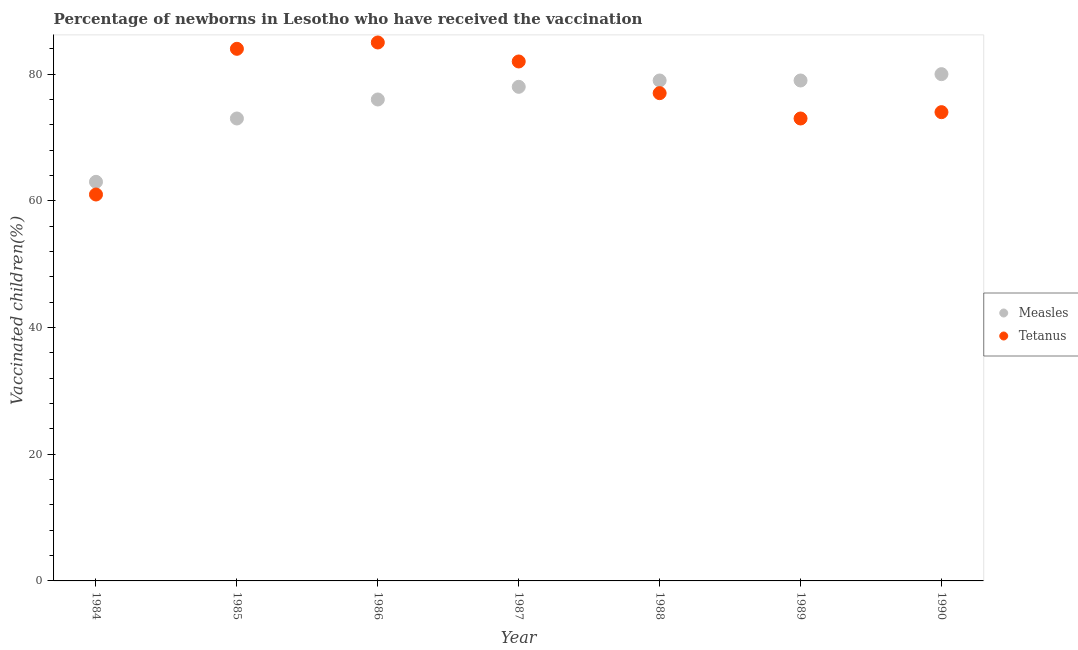What is the percentage of newborns who received vaccination for measles in 1985?
Make the answer very short. 73. Across all years, what is the maximum percentage of newborns who received vaccination for measles?
Ensure brevity in your answer.  80. Across all years, what is the minimum percentage of newborns who received vaccination for tetanus?
Your answer should be very brief. 61. What is the total percentage of newborns who received vaccination for tetanus in the graph?
Your response must be concise. 536. What is the difference between the percentage of newborns who received vaccination for tetanus in 1985 and that in 1990?
Your answer should be very brief. 10. What is the difference between the percentage of newborns who received vaccination for measles in 1986 and the percentage of newborns who received vaccination for tetanus in 1984?
Your response must be concise. 15. What is the average percentage of newborns who received vaccination for measles per year?
Provide a short and direct response. 75.43. In the year 1986, what is the difference between the percentage of newborns who received vaccination for measles and percentage of newborns who received vaccination for tetanus?
Your response must be concise. -9. What is the ratio of the percentage of newborns who received vaccination for measles in 1984 to that in 1989?
Your answer should be compact. 0.8. Is the percentage of newborns who received vaccination for measles in 1988 less than that in 1990?
Offer a very short reply. Yes. What is the difference between the highest and the second highest percentage of newborns who received vaccination for tetanus?
Your response must be concise. 1. What is the difference between the highest and the lowest percentage of newborns who received vaccination for measles?
Provide a short and direct response. 17. Is the percentage of newborns who received vaccination for tetanus strictly greater than the percentage of newborns who received vaccination for measles over the years?
Provide a succinct answer. No. How many dotlines are there?
Make the answer very short. 2. What is the difference between two consecutive major ticks on the Y-axis?
Provide a succinct answer. 20. Does the graph contain any zero values?
Provide a succinct answer. No. Where does the legend appear in the graph?
Keep it short and to the point. Center right. How many legend labels are there?
Your answer should be compact. 2. What is the title of the graph?
Make the answer very short. Percentage of newborns in Lesotho who have received the vaccination. What is the label or title of the Y-axis?
Your answer should be compact. Vaccinated children(%)
. What is the Vaccinated children(%)
 of Measles in 1984?
Provide a succinct answer. 63. What is the Vaccinated children(%)
 in Measles in 1986?
Offer a terse response. 76. What is the Vaccinated children(%)
 in Measles in 1988?
Make the answer very short. 79. What is the Vaccinated children(%)
 in Tetanus in 1988?
Offer a terse response. 77. What is the Vaccinated children(%)
 of Measles in 1989?
Provide a succinct answer. 79. What is the Vaccinated children(%)
 of Tetanus in 1989?
Make the answer very short. 73. What is the Vaccinated children(%)
 of Tetanus in 1990?
Provide a succinct answer. 74. Across all years, what is the maximum Vaccinated children(%)
 in Measles?
Give a very brief answer. 80. Across all years, what is the maximum Vaccinated children(%)
 in Tetanus?
Ensure brevity in your answer.  85. Across all years, what is the minimum Vaccinated children(%)
 of Measles?
Offer a very short reply. 63. Across all years, what is the minimum Vaccinated children(%)
 in Tetanus?
Keep it short and to the point. 61. What is the total Vaccinated children(%)
 of Measles in the graph?
Your answer should be compact. 528. What is the total Vaccinated children(%)
 in Tetanus in the graph?
Your answer should be compact. 536. What is the difference between the Vaccinated children(%)
 in Measles in 1984 and that in 1985?
Ensure brevity in your answer.  -10. What is the difference between the Vaccinated children(%)
 of Tetanus in 1984 and that in 1985?
Provide a short and direct response. -23. What is the difference between the Vaccinated children(%)
 in Measles in 1984 and that in 1986?
Your response must be concise. -13. What is the difference between the Vaccinated children(%)
 of Measles in 1984 and that in 1987?
Your response must be concise. -15. What is the difference between the Vaccinated children(%)
 of Tetanus in 1984 and that in 1987?
Offer a very short reply. -21. What is the difference between the Vaccinated children(%)
 of Measles in 1984 and that in 1988?
Your response must be concise. -16. What is the difference between the Vaccinated children(%)
 in Measles in 1984 and that in 1989?
Offer a terse response. -16. What is the difference between the Vaccinated children(%)
 of Tetanus in 1985 and that in 1986?
Keep it short and to the point. -1. What is the difference between the Vaccinated children(%)
 in Tetanus in 1985 and that in 1987?
Your answer should be compact. 2. What is the difference between the Vaccinated children(%)
 in Tetanus in 1985 and that in 1988?
Make the answer very short. 7. What is the difference between the Vaccinated children(%)
 in Tetanus in 1985 and that in 1989?
Keep it short and to the point. 11. What is the difference between the Vaccinated children(%)
 of Measles in 1985 and that in 1990?
Ensure brevity in your answer.  -7. What is the difference between the Vaccinated children(%)
 in Tetanus in 1985 and that in 1990?
Provide a succinct answer. 10. What is the difference between the Vaccinated children(%)
 in Measles in 1986 and that in 1987?
Ensure brevity in your answer.  -2. What is the difference between the Vaccinated children(%)
 of Tetanus in 1986 and that in 1989?
Your answer should be compact. 12. What is the difference between the Vaccinated children(%)
 of Tetanus in 1986 and that in 1990?
Your answer should be very brief. 11. What is the difference between the Vaccinated children(%)
 of Measles in 1987 and that in 1988?
Give a very brief answer. -1. What is the difference between the Vaccinated children(%)
 in Tetanus in 1987 and that in 1988?
Offer a terse response. 5. What is the difference between the Vaccinated children(%)
 in Tetanus in 1987 and that in 1990?
Your answer should be very brief. 8. What is the difference between the Vaccinated children(%)
 of Measles in 1988 and that in 1989?
Keep it short and to the point. 0. What is the difference between the Vaccinated children(%)
 in Tetanus in 1988 and that in 1989?
Make the answer very short. 4. What is the difference between the Vaccinated children(%)
 in Measles in 1989 and that in 1990?
Offer a very short reply. -1. What is the difference between the Vaccinated children(%)
 of Measles in 1984 and the Vaccinated children(%)
 of Tetanus in 1988?
Offer a very short reply. -14. What is the difference between the Vaccinated children(%)
 of Measles in 1985 and the Vaccinated children(%)
 of Tetanus in 1987?
Ensure brevity in your answer.  -9. What is the difference between the Vaccinated children(%)
 of Measles in 1985 and the Vaccinated children(%)
 of Tetanus in 1988?
Ensure brevity in your answer.  -4. What is the difference between the Vaccinated children(%)
 in Measles in 1985 and the Vaccinated children(%)
 in Tetanus in 1989?
Ensure brevity in your answer.  0. What is the difference between the Vaccinated children(%)
 in Measles in 1985 and the Vaccinated children(%)
 in Tetanus in 1990?
Your response must be concise. -1. What is the difference between the Vaccinated children(%)
 in Measles in 1986 and the Vaccinated children(%)
 in Tetanus in 1987?
Provide a succinct answer. -6. What is the difference between the Vaccinated children(%)
 of Measles in 1986 and the Vaccinated children(%)
 of Tetanus in 1989?
Offer a very short reply. 3. What is the difference between the Vaccinated children(%)
 in Measles in 1987 and the Vaccinated children(%)
 in Tetanus in 1990?
Make the answer very short. 4. What is the difference between the Vaccinated children(%)
 of Measles in 1988 and the Vaccinated children(%)
 of Tetanus in 1990?
Your answer should be compact. 5. What is the difference between the Vaccinated children(%)
 in Measles in 1989 and the Vaccinated children(%)
 in Tetanus in 1990?
Offer a terse response. 5. What is the average Vaccinated children(%)
 in Measles per year?
Ensure brevity in your answer.  75.43. What is the average Vaccinated children(%)
 of Tetanus per year?
Offer a very short reply. 76.57. In the year 1984, what is the difference between the Vaccinated children(%)
 in Measles and Vaccinated children(%)
 in Tetanus?
Your answer should be very brief. 2. In the year 1987, what is the difference between the Vaccinated children(%)
 of Measles and Vaccinated children(%)
 of Tetanus?
Give a very brief answer. -4. In the year 1988, what is the difference between the Vaccinated children(%)
 in Measles and Vaccinated children(%)
 in Tetanus?
Keep it short and to the point. 2. In the year 1989, what is the difference between the Vaccinated children(%)
 in Measles and Vaccinated children(%)
 in Tetanus?
Offer a very short reply. 6. In the year 1990, what is the difference between the Vaccinated children(%)
 in Measles and Vaccinated children(%)
 in Tetanus?
Offer a terse response. 6. What is the ratio of the Vaccinated children(%)
 in Measles in 1984 to that in 1985?
Provide a succinct answer. 0.86. What is the ratio of the Vaccinated children(%)
 in Tetanus in 1984 to that in 1985?
Offer a terse response. 0.73. What is the ratio of the Vaccinated children(%)
 of Measles in 1984 to that in 1986?
Offer a very short reply. 0.83. What is the ratio of the Vaccinated children(%)
 of Tetanus in 1984 to that in 1986?
Provide a short and direct response. 0.72. What is the ratio of the Vaccinated children(%)
 of Measles in 1984 to that in 1987?
Keep it short and to the point. 0.81. What is the ratio of the Vaccinated children(%)
 of Tetanus in 1984 to that in 1987?
Your answer should be very brief. 0.74. What is the ratio of the Vaccinated children(%)
 of Measles in 1984 to that in 1988?
Give a very brief answer. 0.8. What is the ratio of the Vaccinated children(%)
 in Tetanus in 1984 to that in 1988?
Ensure brevity in your answer.  0.79. What is the ratio of the Vaccinated children(%)
 in Measles in 1984 to that in 1989?
Keep it short and to the point. 0.8. What is the ratio of the Vaccinated children(%)
 in Tetanus in 1984 to that in 1989?
Keep it short and to the point. 0.84. What is the ratio of the Vaccinated children(%)
 of Measles in 1984 to that in 1990?
Keep it short and to the point. 0.79. What is the ratio of the Vaccinated children(%)
 of Tetanus in 1984 to that in 1990?
Your answer should be very brief. 0.82. What is the ratio of the Vaccinated children(%)
 of Measles in 1985 to that in 1986?
Your answer should be very brief. 0.96. What is the ratio of the Vaccinated children(%)
 in Measles in 1985 to that in 1987?
Give a very brief answer. 0.94. What is the ratio of the Vaccinated children(%)
 of Tetanus in 1985 to that in 1987?
Ensure brevity in your answer.  1.02. What is the ratio of the Vaccinated children(%)
 of Measles in 1985 to that in 1988?
Your answer should be compact. 0.92. What is the ratio of the Vaccinated children(%)
 of Tetanus in 1985 to that in 1988?
Your answer should be very brief. 1.09. What is the ratio of the Vaccinated children(%)
 of Measles in 1985 to that in 1989?
Give a very brief answer. 0.92. What is the ratio of the Vaccinated children(%)
 in Tetanus in 1985 to that in 1989?
Your response must be concise. 1.15. What is the ratio of the Vaccinated children(%)
 of Measles in 1985 to that in 1990?
Your answer should be compact. 0.91. What is the ratio of the Vaccinated children(%)
 of Tetanus in 1985 to that in 1990?
Provide a succinct answer. 1.14. What is the ratio of the Vaccinated children(%)
 in Measles in 1986 to that in 1987?
Offer a terse response. 0.97. What is the ratio of the Vaccinated children(%)
 in Tetanus in 1986 to that in 1987?
Provide a succinct answer. 1.04. What is the ratio of the Vaccinated children(%)
 of Tetanus in 1986 to that in 1988?
Your answer should be compact. 1.1. What is the ratio of the Vaccinated children(%)
 of Tetanus in 1986 to that in 1989?
Keep it short and to the point. 1.16. What is the ratio of the Vaccinated children(%)
 of Measles in 1986 to that in 1990?
Keep it short and to the point. 0.95. What is the ratio of the Vaccinated children(%)
 in Tetanus in 1986 to that in 1990?
Your answer should be very brief. 1.15. What is the ratio of the Vaccinated children(%)
 of Measles in 1987 to that in 1988?
Make the answer very short. 0.99. What is the ratio of the Vaccinated children(%)
 of Tetanus in 1987 to that in 1988?
Keep it short and to the point. 1.06. What is the ratio of the Vaccinated children(%)
 of Measles in 1987 to that in 1989?
Make the answer very short. 0.99. What is the ratio of the Vaccinated children(%)
 of Tetanus in 1987 to that in 1989?
Offer a very short reply. 1.12. What is the ratio of the Vaccinated children(%)
 of Tetanus in 1987 to that in 1990?
Your answer should be compact. 1.11. What is the ratio of the Vaccinated children(%)
 in Tetanus in 1988 to that in 1989?
Keep it short and to the point. 1.05. What is the ratio of the Vaccinated children(%)
 of Measles in 1988 to that in 1990?
Make the answer very short. 0.99. What is the ratio of the Vaccinated children(%)
 in Tetanus in 1988 to that in 1990?
Provide a succinct answer. 1.04. What is the ratio of the Vaccinated children(%)
 in Measles in 1989 to that in 1990?
Keep it short and to the point. 0.99. What is the ratio of the Vaccinated children(%)
 in Tetanus in 1989 to that in 1990?
Keep it short and to the point. 0.99. What is the difference between the highest and the second highest Vaccinated children(%)
 of Measles?
Your response must be concise. 1. What is the difference between the highest and the second highest Vaccinated children(%)
 of Tetanus?
Provide a succinct answer. 1. What is the difference between the highest and the lowest Vaccinated children(%)
 in Tetanus?
Offer a terse response. 24. 